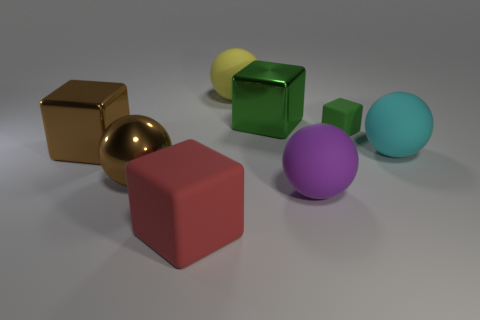There is a large cyan rubber object; what number of big cyan rubber things are behind it?
Offer a very short reply. 0. Is the shape of the cyan object the same as the matte thing that is in front of the big purple object?
Your answer should be compact. No. Are there any big brown things of the same shape as the tiny green thing?
Provide a succinct answer. Yes. What shape is the large brown metallic object behind the big rubber ball on the right side of the purple rubber sphere?
Keep it short and to the point. Cube. There is a metallic object in front of the cyan sphere; what shape is it?
Keep it short and to the point. Sphere. There is a rubber cube that is on the right side of the red rubber cube; is it the same color as the shiny object that is to the right of the red thing?
Your answer should be compact. Yes. How many big objects are both behind the brown metal sphere and right of the metal ball?
Your answer should be very brief. 3. There is a purple object that is the same material as the big red thing; what is its size?
Your answer should be compact. Large. The green rubber cube is what size?
Give a very brief answer. Small. What material is the big green cube?
Offer a very short reply. Metal. 